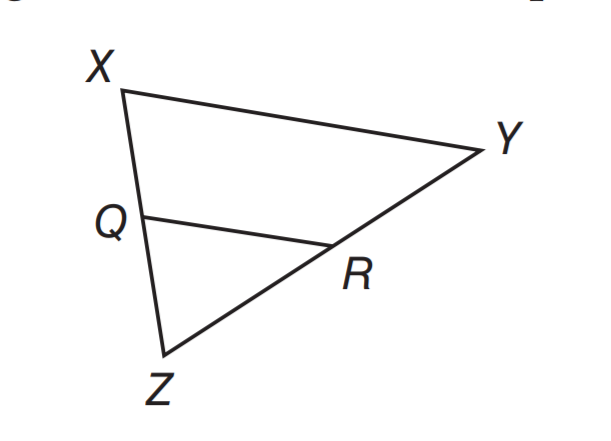Answer the mathemtical geometry problem and directly provide the correct option letter.
Question: If Q R \parallel X Y, X Q \cong Q Z, and Q R = 9.5 units, what is the length of X Y.
Choices: A: 4.75 B: 9.5 C: 19 D: 28.5 C 